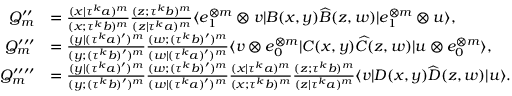Convert formula to latex. <formula><loc_0><loc_0><loc_500><loc_500>\begin{array} { r l } { Q _ { m } ^ { \prime \prime } } & { = \frac { ( x | \tau ^ { k } a ) ^ { m } } { ( x ; \tau ^ { k } b ) ^ { m } } \frac { ( z ; \tau ^ { k } b ) ^ { m } } { ( z | \tau ^ { k } a ) ^ { m } } \langle e _ { 1 } ^ { \otimes m } \otimes v | B ( x , y ) \widehat { B } ( z , w ) | e _ { 1 } ^ { \otimes m } \otimes u \rangle , } \\ { Q _ { m } ^ { \prime \prime \prime } } & { = \frac { ( y | ( \tau ^ { k } a ) ^ { \prime } ) ^ { m } } { ( y ; ( \tau ^ { k } b ) ^ { \prime } ) ^ { m } } \frac { ( w ; ( \tau ^ { k } b ) ^ { \prime } ) ^ { m } } { ( w | ( \tau ^ { k } a ) ^ { \prime } ) ^ { m } } \langle v \otimes e _ { 0 } ^ { \otimes m } | C ( x , y ) \widehat { C } ( z , w ) | u \otimes e _ { 0 } ^ { \otimes m } \rangle , } \\ { Q _ { m } ^ { \prime \prime \prime \prime } } & { = \frac { ( y | ( \tau ^ { k } a ) ^ { \prime } ) ^ { m } } { ( y ; ( \tau ^ { k } b ) ^ { \prime } ) ^ { m } } \frac { ( w ; ( \tau ^ { k } b ) ^ { \prime } ) ^ { m } } { ( w | ( \tau ^ { k } a ) ^ { \prime } ) ^ { m } } \frac { ( x | \tau ^ { k } a ) ^ { m } } { ( x ; \tau ^ { k } b ) ^ { m } } \frac { ( z ; \tau ^ { k } b ) ^ { m } } { ( z | \tau ^ { k } a ) ^ { m } } \langle v | D ( x , y ) \widehat { D } ( z , w ) | u \rangle . } \end{array}</formula> 